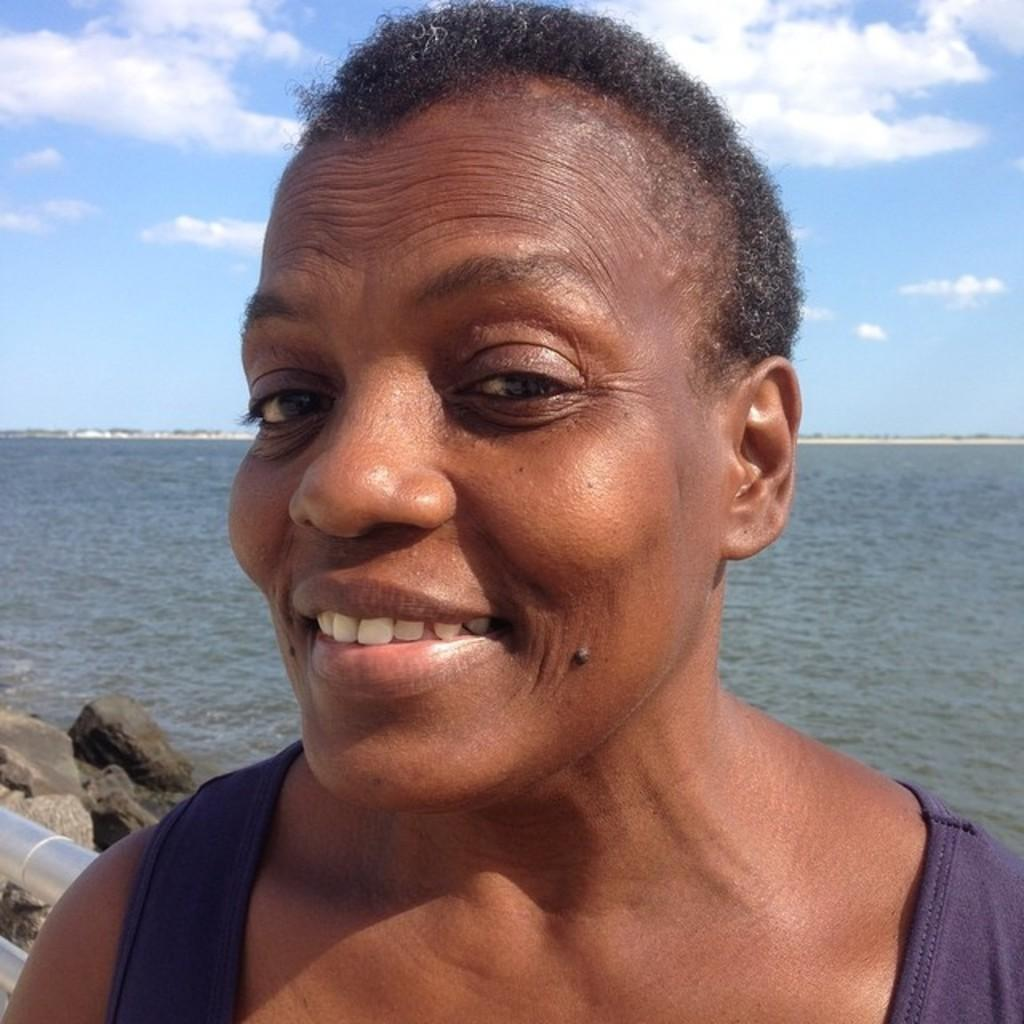What is the main subject of the image? The main subject of the image is a woman. What is the woman wearing in the image? The woman is wearing a purple dress in the image. What is the woman's facial expression in the image? The woman is smiling in the image. What can be seen in the background of the image? Water, clouds, and the sky are visible in the background of the image. Is there a beggar asking for money in the image? There is no beggar present in the image. What type of bell can be heard ringing in the background of the image? There is no bell present or audible in the image. 